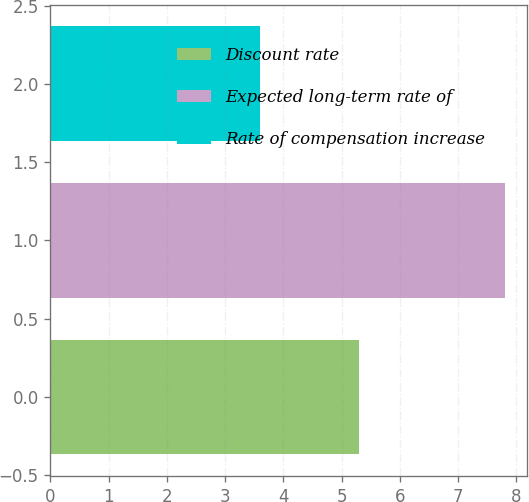Convert chart. <chart><loc_0><loc_0><loc_500><loc_500><bar_chart><fcel>Discount rate<fcel>Expected long-term rate of<fcel>Rate of compensation increase<nl><fcel>5.3<fcel>7.8<fcel>3.6<nl></chart> 